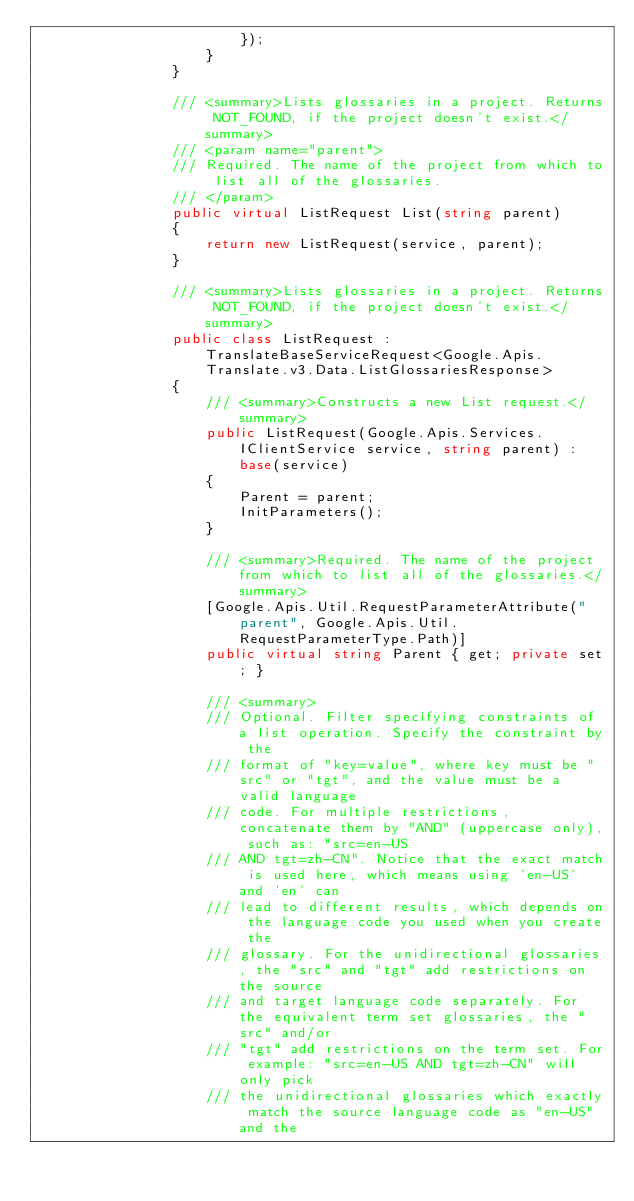Convert code to text. <code><loc_0><loc_0><loc_500><loc_500><_C#_>                        });
                    }
                }

                /// <summary>Lists glossaries in a project. Returns NOT_FOUND, if the project doesn't exist.</summary>
                /// <param name="parent">
                /// Required. The name of the project from which to list all of the glossaries.
                /// </param>
                public virtual ListRequest List(string parent)
                {
                    return new ListRequest(service, parent);
                }

                /// <summary>Lists glossaries in a project. Returns NOT_FOUND, if the project doesn't exist.</summary>
                public class ListRequest : TranslateBaseServiceRequest<Google.Apis.Translate.v3.Data.ListGlossariesResponse>
                {
                    /// <summary>Constructs a new List request.</summary>
                    public ListRequest(Google.Apis.Services.IClientService service, string parent) : base(service)
                    {
                        Parent = parent;
                        InitParameters();
                    }

                    /// <summary>Required. The name of the project from which to list all of the glossaries.</summary>
                    [Google.Apis.Util.RequestParameterAttribute("parent", Google.Apis.Util.RequestParameterType.Path)]
                    public virtual string Parent { get; private set; }

                    /// <summary>
                    /// Optional. Filter specifying constraints of a list operation. Specify the constraint by the
                    /// format of "key=value", where key must be "src" or "tgt", and the value must be a valid language
                    /// code. For multiple restrictions, concatenate them by "AND" (uppercase only), such as: "src=en-US
                    /// AND tgt=zh-CN". Notice that the exact match is used here, which means using 'en-US' and 'en' can
                    /// lead to different results, which depends on the language code you used when you create the
                    /// glossary. For the unidirectional glossaries, the "src" and "tgt" add restrictions on the source
                    /// and target language code separately. For the equivalent term set glossaries, the "src" and/or
                    /// "tgt" add restrictions on the term set. For example: "src=en-US AND tgt=zh-CN" will only pick
                    /// the unidirectional glossaries which exactly match the source language code as "en-US" and the</code> 